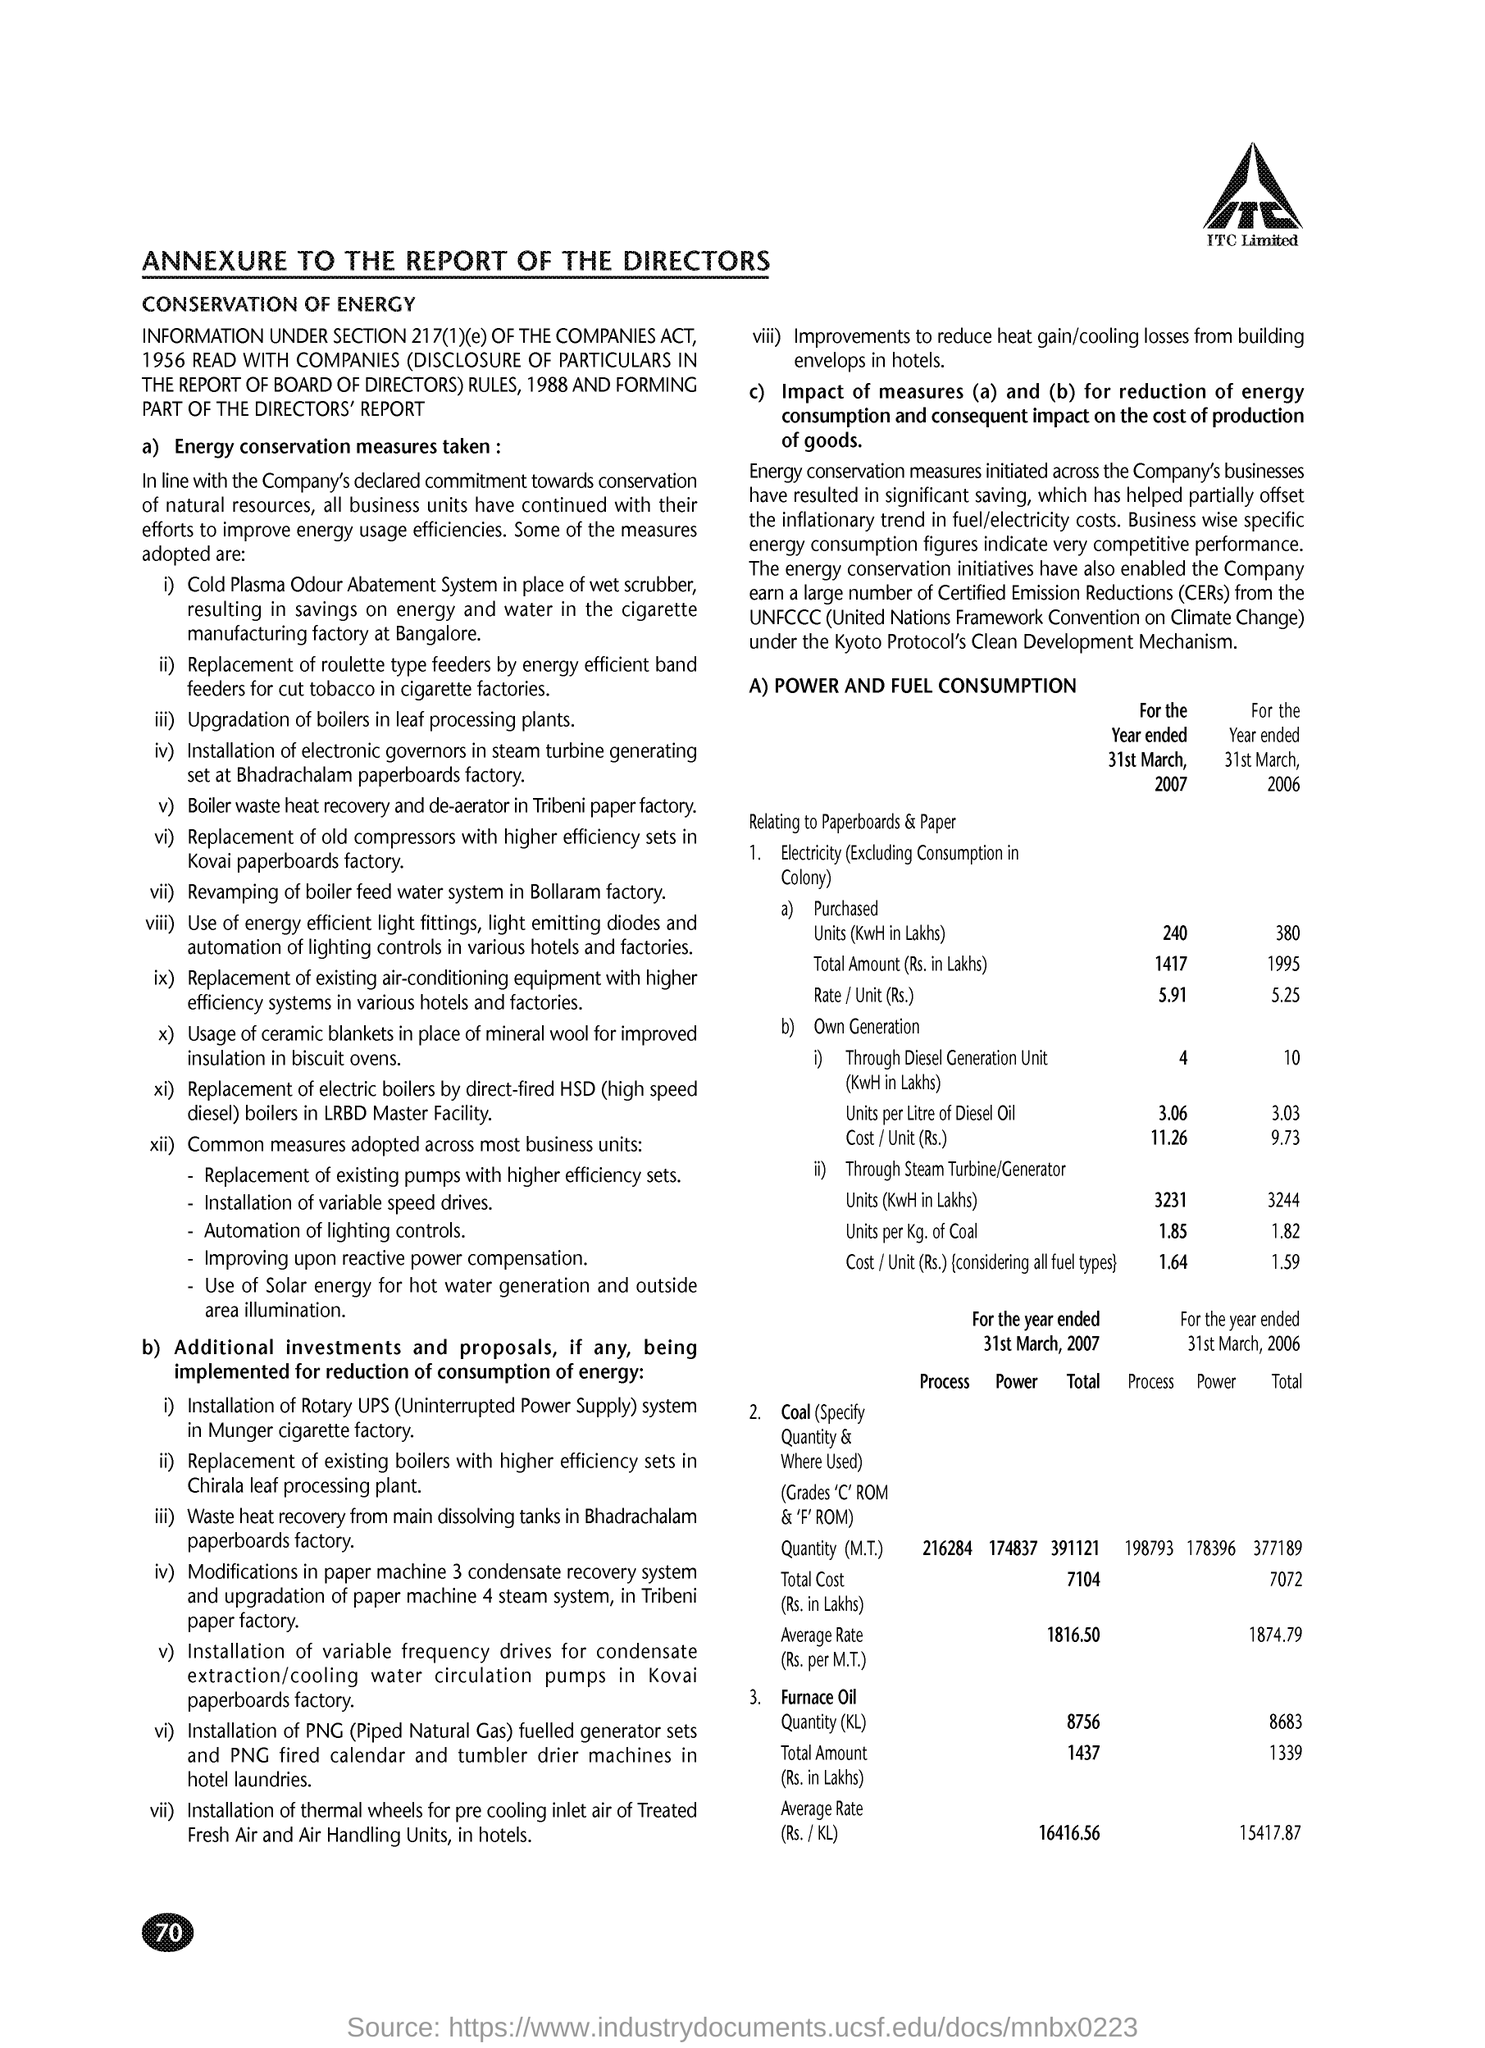What is the Page Number?
Offer a very short reply. 70. 